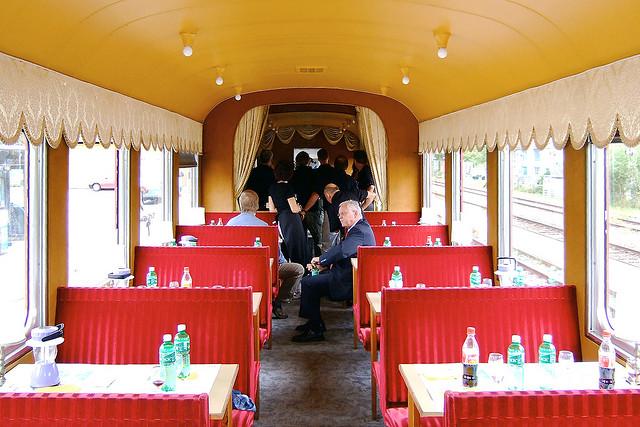What color are the window curtains?
Quick response, please. White. Is this a train car?
Answer briefly. Yes. How many bottles are in the front, left table?
Keep it brief. 2. 